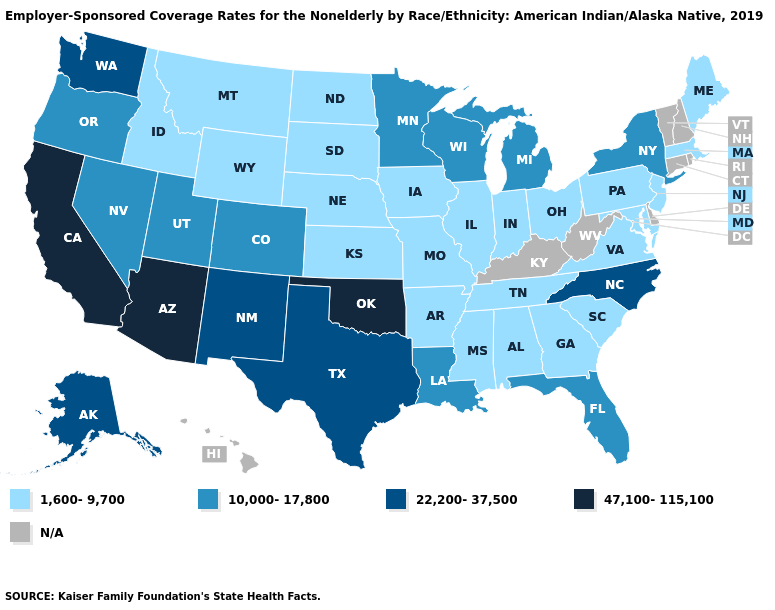Which states hav the highest value in the Northeast?
Concise answer only. New York. Name the states that have a value in the range 22,200-37,500?
Answer briefly. Alaska, New Mexico, North Carolina, Texas, Washington. Does the map have missing data?
Concise answer only. Yes. Is the legend a continuous bar?
Keep it brief. No. Which states have the highest value in the USA?
Concise answer only. Arizona, California, Oklahoma. Name the states that have a value in the range N/A?
Give a very brief answer. Connecticut, Delaware, Hawaii, Kentucky, New Hampshire, Rhode Island, Vermont, West Virginia. Does Washington have the lowest value in the USA?
Give a very brief answer. No. Does the map have missing data?
Concise answer only. Yes. Does the map have missing data?
Concise answer only. Yes. Does Oklahoma have the highest value in the USA?
Be succinct. Yes. Name the states that have a value in the range 22,200-37,500?
Be succinct. Alaska, New Mexico, North Carolina, Texas, Washington. Name the states that have a value in the range N/A?
Be succinct. Connecticut, Delaware, Hawaii, Kentucky, New Hampshire, Rhode Island, Vermont, West Virginia. Name the states that have a value in the range 22,200-37,500?
Quick response, please. Alaska, New Mexico, North Carolina, Texas, Washington. Name the states that have a value in the range 1,600-9,700?
Give a very brief answer. Alabama, Arkansas, Georgia, Idaho, Illinois, Indiana, Iowa, Kansas, Maine, Maryland, Massachusetts, Mississippi, Missouri, Montana, Nebraska, New Jersey, North Dakota, Ohio, Pennsylvania, South Carolina, South Dakota, Tennessee, Virginia, Wyoming. 